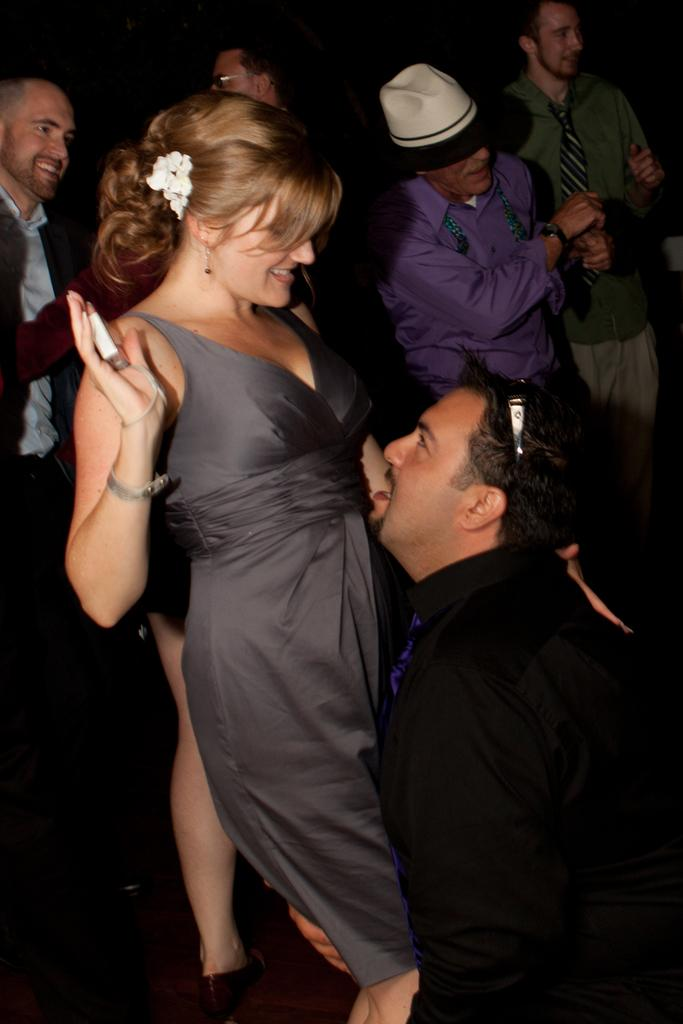What are the main subjects of the image? There is a couple dancing in the image. Are there any other people present in the image? Yes, there are other people standing behind the couple. What is the mood of the people standing behind the couple? The people standing behind the couple are smiling, which suggests a positive mood. What type of mark can be seen on the floor where the couple is dancing? There is no mark visible on the floor where the couple is dancing in the image. What sound can be heard coming from the horses in the image? There are no horses present in the image, so no sounds can be heard from them. 